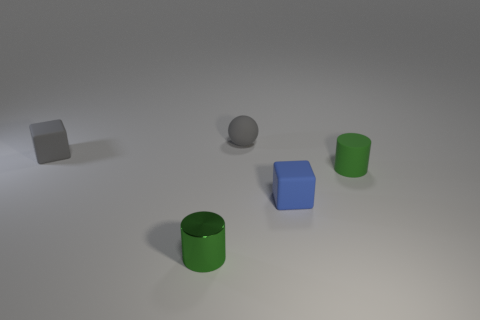Add 3 tiny metallic cylinders. How many objects exist? 8 Add 3 metal cylinders. How many metal cylinders are left? 4 Add 4 blue cubes. How many blue cubes exist? 5 Subtract 0 purple blocks. How many objects are left? 5 Subtract all spheres. How many objects are left? 4 Subtract 2 cylinders. How many cylinders are left? 0 Subtract all gray blocks. Subtract all purple balls. How many blocks are left? 1 Subtract all red blocks. How many cyan balls are left? 0 Subtract all gray rubber spheres. Subtract all small blue blocks. How many objects are left? 3 